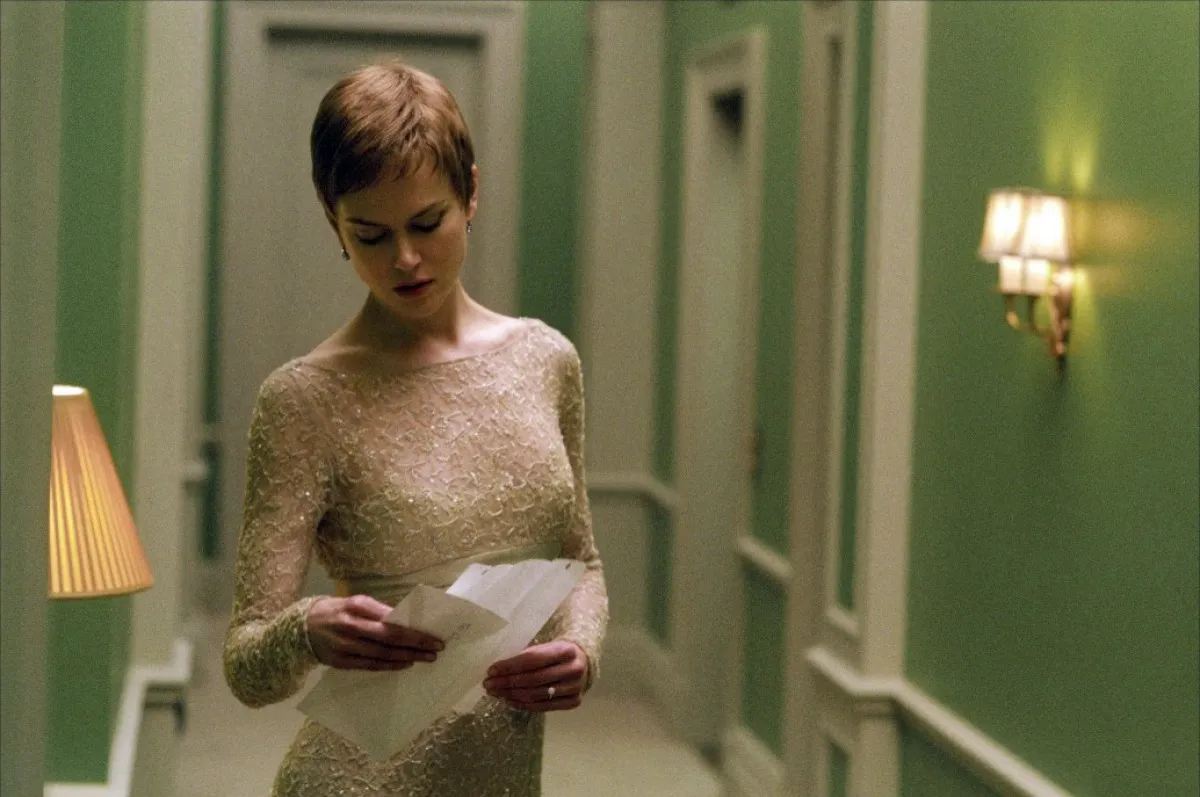How does the setting contribute to the overall mood of the image? The calming green color of the hallway and the soft lighting from the wall lamp and floor lamp contribute to a tranquil and reflective mood, emphasizing the woman's introspective stance as she reads the document. Can you describe any significant details about the woman's dress? Sure, her dress is crafted from intricate lace with a delicate pattern, highlighting a formal and refined style. The dress is form-fitting and features a scalloped neckline, enhancing her poised and elegant appearance. 